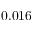<formula> <loc_0><loc_0><loc_500><loc_500>0 . 0 1 6</formula> 